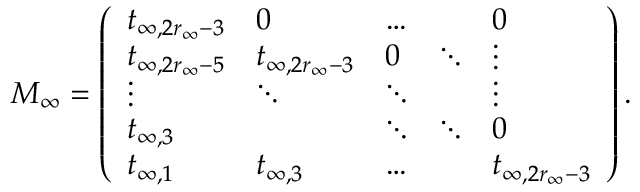Convert formula to latex. <formula><loc_0><loc_0><loc_500><loc_500>M _ { \infty } = \left ( \begin{array} { l l l l l } { t _ { \infty , 2 r _ { \infty } - 3 } } & { 0 } & { \dots } & & { 0 } \\ { t _ { \infty , 2 r _ { \infty } - 5 } } & { t _ { \infty , 2 r _ { \infty } - 3 } } & { 0 } & { \ddots } & { \vdots } \\ { \vdots } & { \ddots } & { \ddots } & & { \vdots } \\ { t _ { \infty , 3 } } & & { \ddots } & { \ddots } & { 0 } \\ { t _ { \infty , 1 } } & { t _ { \infty , 3 } } & { \dots } & & { t _ { \infty , 2 r _ { \infty } - 3 } } \end{array} \right ) .</formula> 